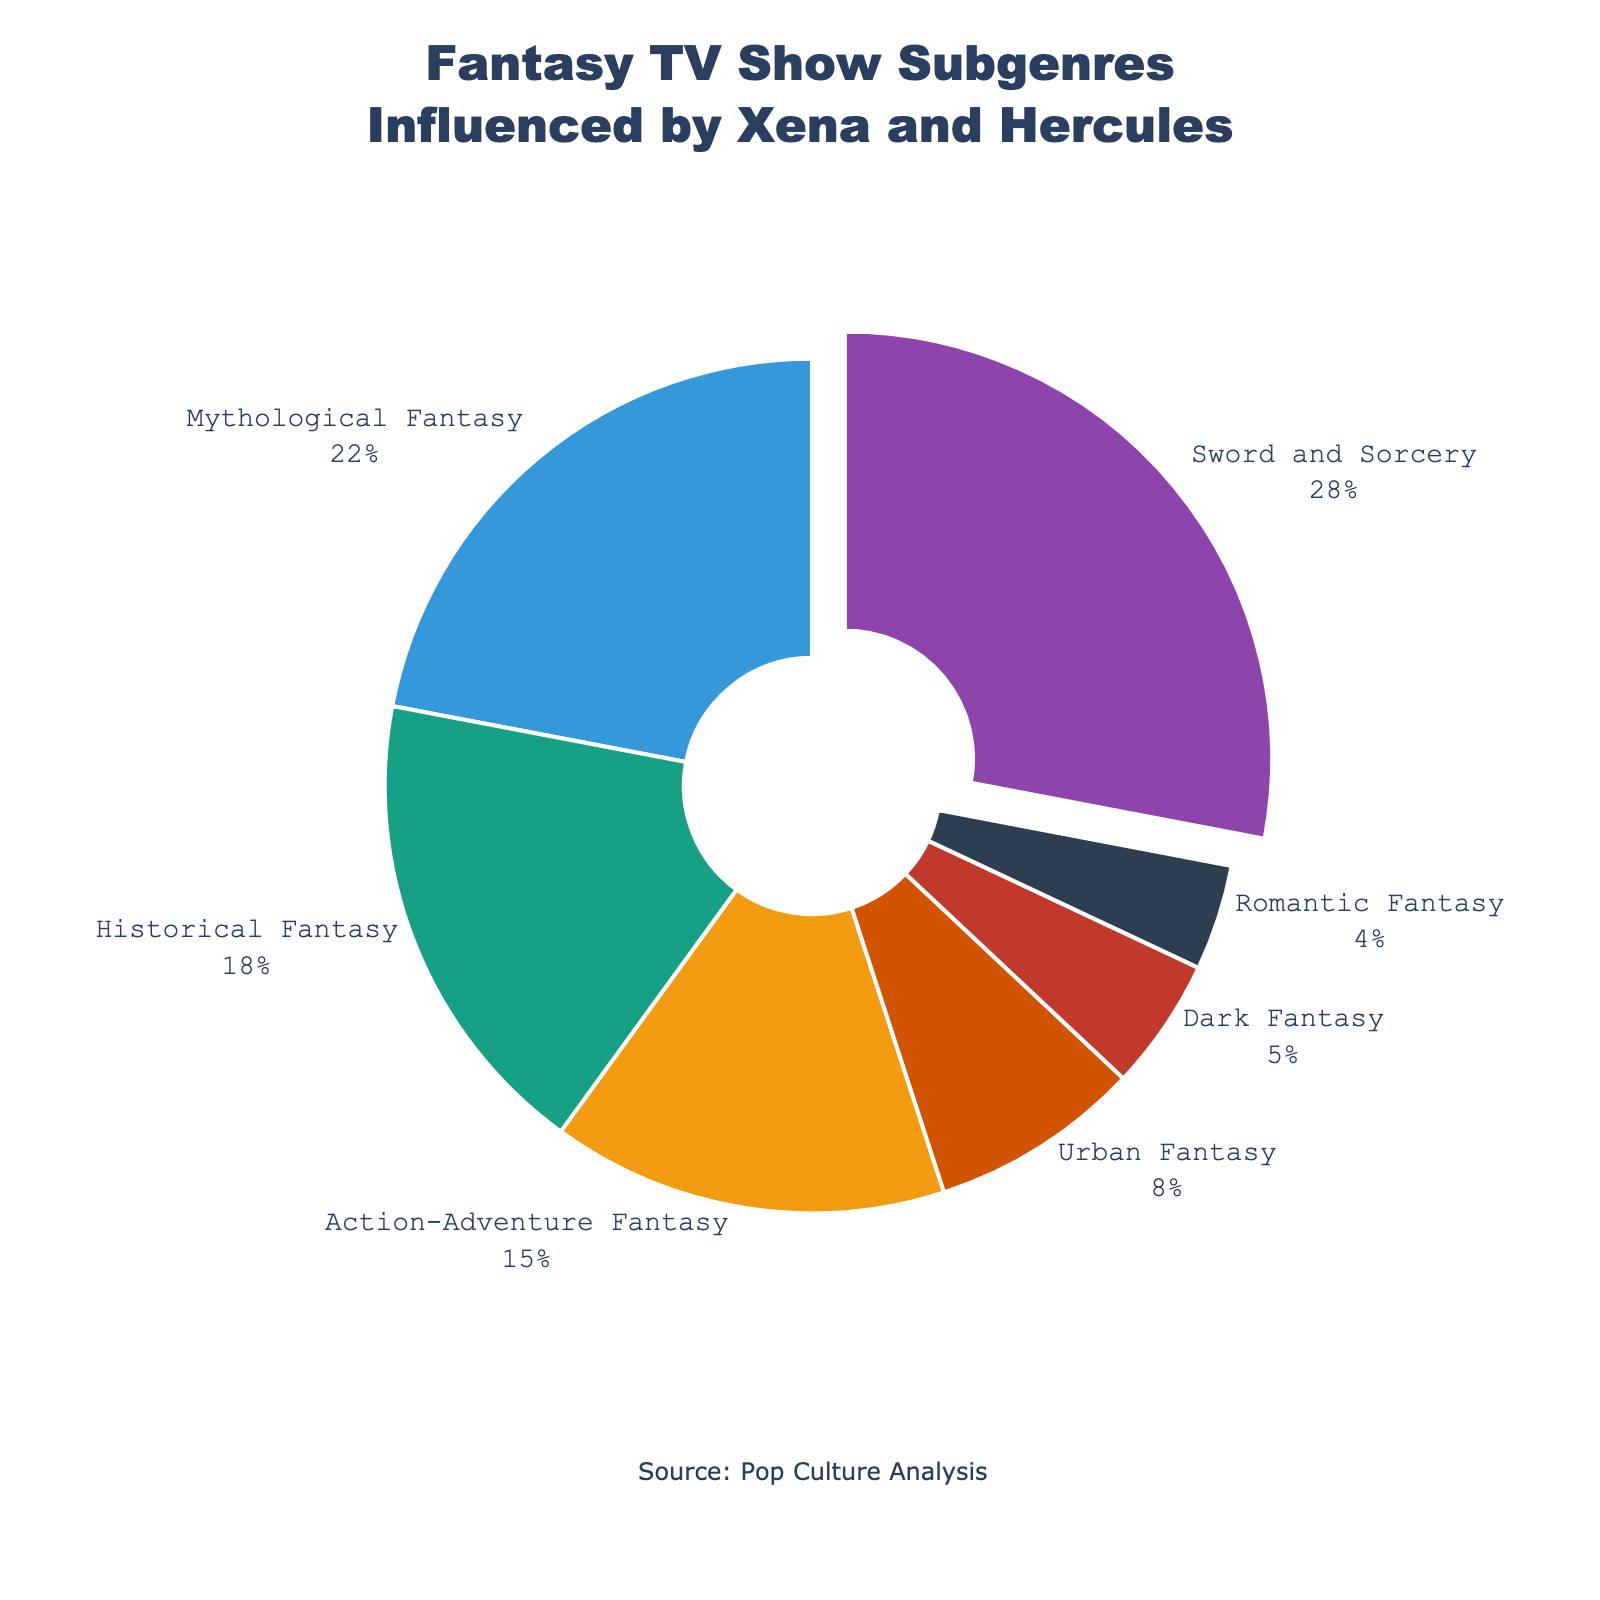Which subgenre has the largest percentage in the distribution? The largest percentage can be found by identifying the subgenre with the largest section in the pie chart or the one pulled out. In this case, it's Sword and Sorcery.
Answer: Sword and Sorcery What is the combined percentage of Urban Fantasy and Dark Fantasy? To find the combined percentage, sum up the values for Urban Fantasy (8%) and Dark Fantasy (5%). 8 + 5 = 13
Answer: 13% Which subgenre has a larger percentage, Mythological Fantasy or Historical Fantasy? Compare the percentages for Mythological Fantasy (22%) and Historical Fantasy (18%). Mythological Fantasy has a larger percentage.
Answer: Mythological Fantasy What is the difference in percentage between the largest and smallest subgenres? Identify the subgenres with the largest (Sword and Sorcery, 28%) and smallest (Romantic Fantasy, 4%) percentages, then subtract the smallest from the largest. 28 - 4 = 24
Answer: 24% How many subgenres have a percentage greater than 10%? Count the number of subgenres with percentages greater than 10%: Sword and Sorcery (28%), Mythological Fantasy (22%), Historical Fantasy (18%), and Action-Adventure Fantasy (15%) make 4.
Answer: 4 If we add the percentage of Romantic Fantasy to Action-Adventure Fantasy, does it surpass Historical Fantasy? Add the percentages of Romantic Fantasy (4%) and Action-Adventure Fantasy (15%) to see if it surpasses Historical Fantasy (18%). 4 + 15 = 19, which is greater than 18%.
Answer: Yes What percentage of the subgenres together is represented by Sword and Sorcery and Action-Adventure Fantasy? Sum the percentages for Sword and Sorcery (28%) and Action-Adventure Fantasy (15%). 28 + 15 = 43
Answer: 43% Is the percentage of Dark Fantasy smaller than the percentage of Urban Fantasy? Compare the percentages of Dark Fantasy (5%) and Urban Fantasy (8%). Dark Fantasy has a smaller percentage.
Answer: Yes Which subgenre is displayed in red? To identify which subgenre is in red, look for the subsection colored red in the pie chart. The Urban Fantasy percentage portion is red.
Answer: Urban Fantasy 